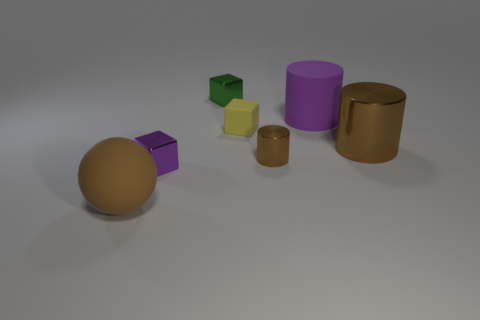Add 2 metal cubes. How many objects exist? 9 Subtract all cylinders. How many objects are left? 4 Subtract 0 gray cubes. How many objects are left? 7 Subtract all big brown cylinders. Subtract all brown rubber things. How many objects are left? 5 Add 5 large brown matte objects. How many large brown matte objects are left? 6 Add 3 tiny yellow things. How many tiny yellow things exist? 4 